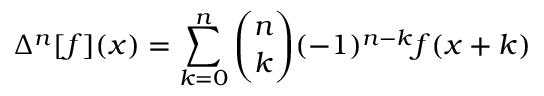Convert formula to latex. <formula><loc_0><loc_0><loc_500><loc_500>\Delta ^ { n } [ f ] ( x ) = \sum _ { k = 0 } ^ { n } { \binom { n } { k } } ( - 1 ) ^ { n - k } f ( x + k )</formula> 